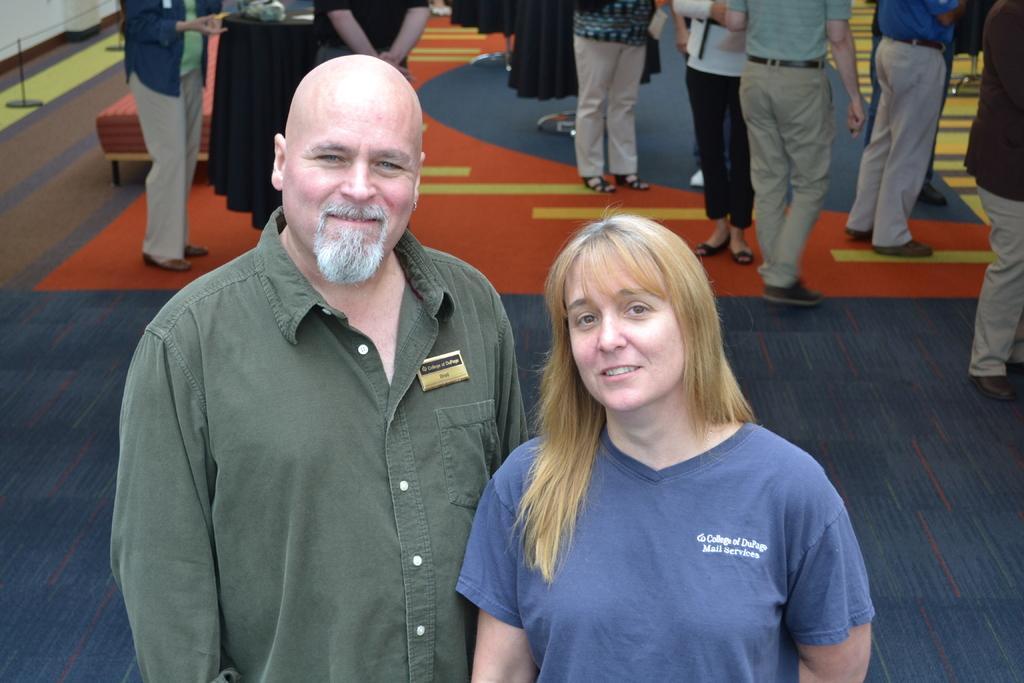Could you give a brief overview of what you see in this image? In this picture we can see a man and a woman standing and smiling and at the back of them we can see a group of people standing on the ground and some objects. 